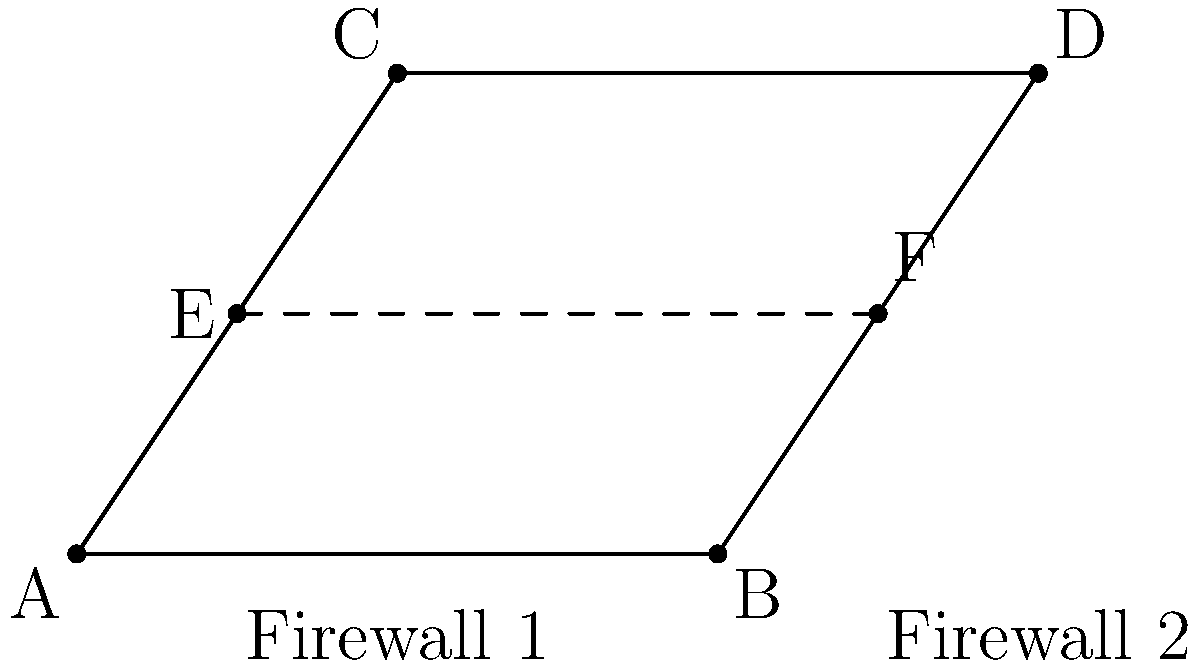In a network security diagram representing two firewalls, congruent segments are used to illustrate identical security measures. Given that $\overline{AB} \cong \overline{CD}$ and $\overline{AE} \cong \overline{BF}$, prove that $\overline{EF}$ is parallel to $\overline{AD}$ and calculate the ratio of $EF$ to $AD$. To prove that $\overline{EF}$ is parallel to $\overline{AD}$ and calculate the ratio of $EF$ to $AD$, we'll follow these steps:

1) Since $\overline{AB} \cong \overline{CD}$, we know that $AB = CD$.

2) $\overline{AE} \cong \overline{BF}$ implies that $AE = BF$.

3) In triangle $AEB$:
   $\frac{AE}{AB} = \frac{E}{B}$ (where $E$ and $B$ are the distances of points $E$ and $F$ from $\overline{AD}$)

4) Similarly, in triangle $CFD$:
   $\frac{BF}{CD} = \frac{F}{D}$ (where $F$ and $D$ are the distances of points $F$ and $D$ from $\overline{AB}$)

5) Since $AE = BF$ and $AB = CD$, we can conclude that $\frac{E}{B} = \frac{F}{D}$.

6) This proportionality implies that $\overline{EF}$ is parallel to $\overline{AD}$ (by the theorem of similar triangles).

7) To calculate the ratio of $EF$ to $AD$:
   $\frac{EF}{AD} = \frac{E}{B} = \frac{AE}{AB}$

8) Since $E$ is the midpoint of $AC$ (as $AE = BF$), we can conclude that $\frac{AE}{AB} = \frac{1}{2}$.

Therefore, $\overline{EF}$ is parallel to $\overline{AD}$, and the ratio of $EF$ to $AD$ is $1:2$ or $0.5$.
Answer: $\overline{EF} \parallel \overline{AD}$; $\frac{EF}{AD} = \frac{1}{2}$ 